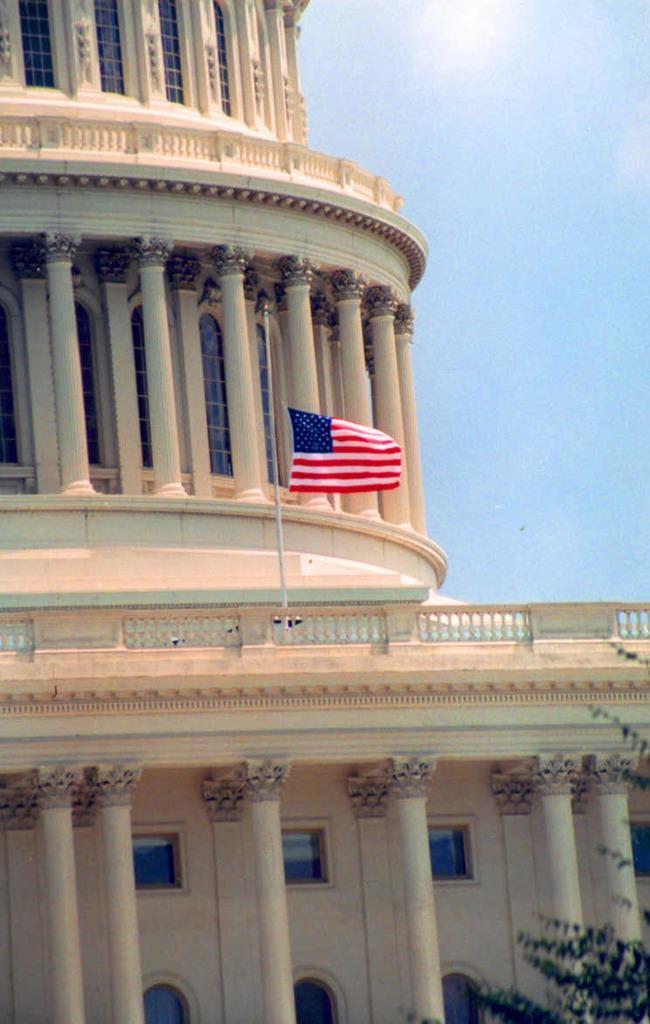Can you describe this image briefly? In this picture, this is building. And this is american flag over it. 